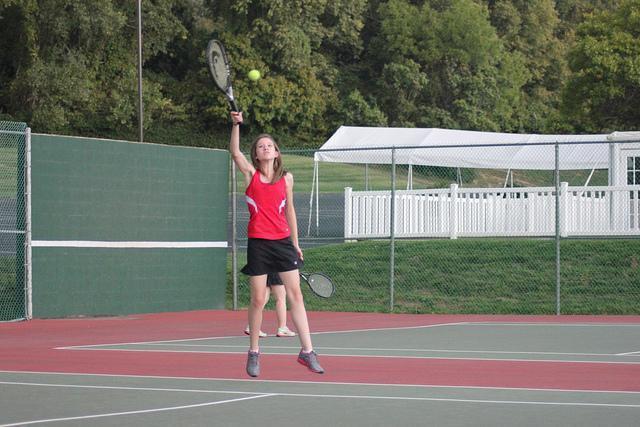How many rackets are there?
Give a very brief answer. 2. How many kites are flying?
Give a very brief answer. 0. 